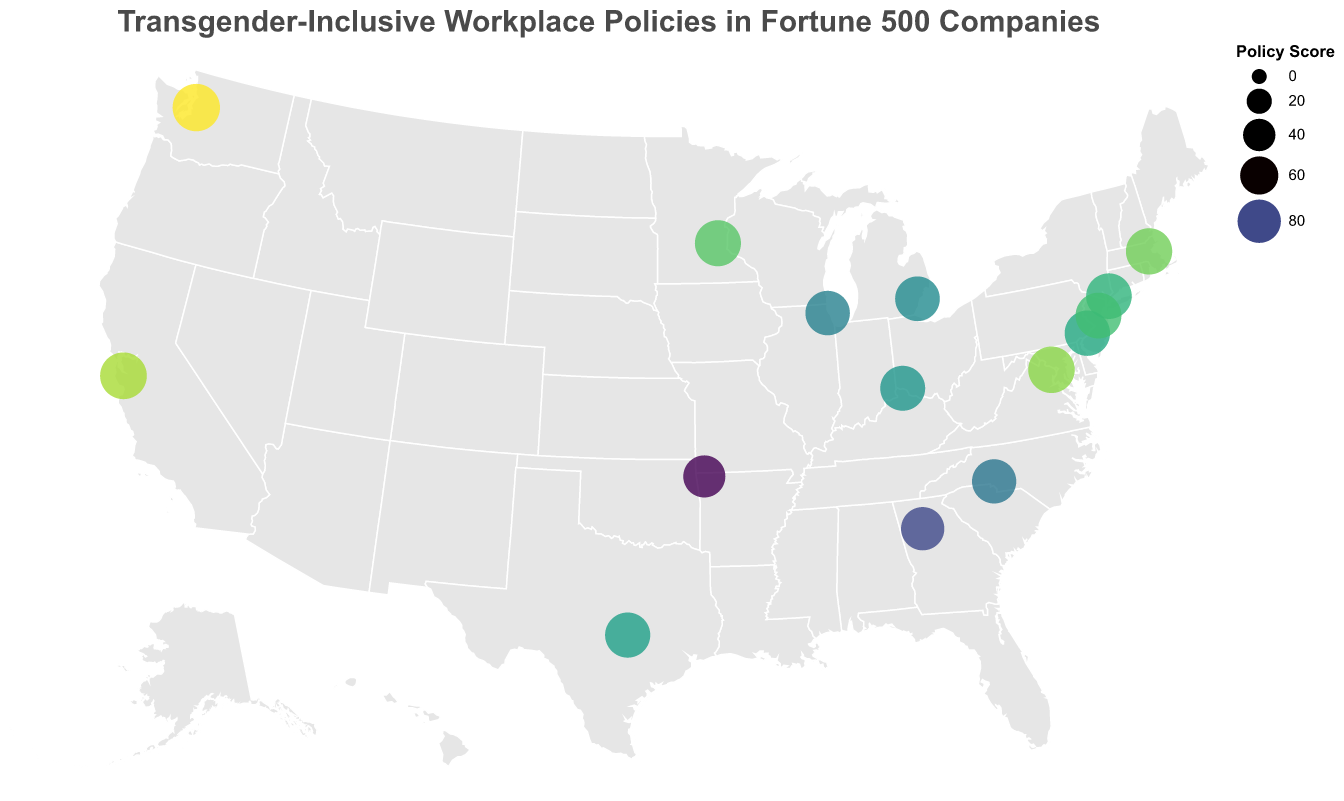What's the title of the plot? The title is displayed prominently at the top of the plot in a larger font.
Answer: Transgender-Inclusive Workplace Policies in Fortune 500 Companies How many companies have a policy score of 90 or higher? Count the circles with policy scores equal to or greater than 90. We have 10 such companies: Apple, IBM, Microsoft, Target, Boston Scientific, Johnson & Johnson, Capital One.
Answer: 10 Which company has the highest transgender-inclusive workplace policy score and where is it headquartered? Identify the circle with the largest size and highest color intensity, then refer to the legend or tooltip for the specific company and its location. In this case, Microsoft in Washington has the highest policy score of 98.
Answer: Microsoft, Washington Which state has the most companies listed in the plot? Identify the state that appears most frequently in the data values. Multiple states can be compared by counting the frequency of companies present in each state. California and New York each have one company listed, but Massachusetts stands out with multiple entries, such as Boston Scientific.
Answer: Massachusetts What is the range of policy scores among these companies? The range is calculated by subtracting the smallest policy score from the largest policy score. Here, the highest policy score is 98 (Microsoft) and the lowest is 75 (Walmart), resulting in a range of 98 - 75 = 23.
Answer: 23 Which company has the lowest policy score and what is it? Identify the smallest circle on the plot and refer to the tooltip to get the company's name and its policy score. Walmart in Arkansas has the lowest policy score of 75.
Answer: Walmart, 75 What is the average policy score of companies headquartered in states on the East Coast (Massachusetts, New York, New Jersey, Virginia)? Add the policy scores of companies headquartered in these states and divide by the number of such companies: (93 + 90 + 91 + 94) / 4 = 92.
Answer: 92 Are there any companies from Texas? If so, what are their policy scores? Check for markers located near the geographical coordinates corresponding to Texas. The tooltip information reveals one company, Dell, with a policy score of 88.
Answer: Yes, Dell with a policy score of 88 What is the median policy score for these companies? Sort the policy scores and find the middle value. The sorted scores are 75, 80, 84, 85, 86, 87, 88, 89, 90, 91, 92, 93, 94, 95, 98. The median score, being the 8th value in this 15-item list, is 89.
Answer: 89 How do California and Washington compare in terms of the policy scores? Compare the policy scores of companies Apple in California (95) and Microsoft in Washington (98). Microsoft has a higher score.
Answer: Microsoft has a higher score than Apple 